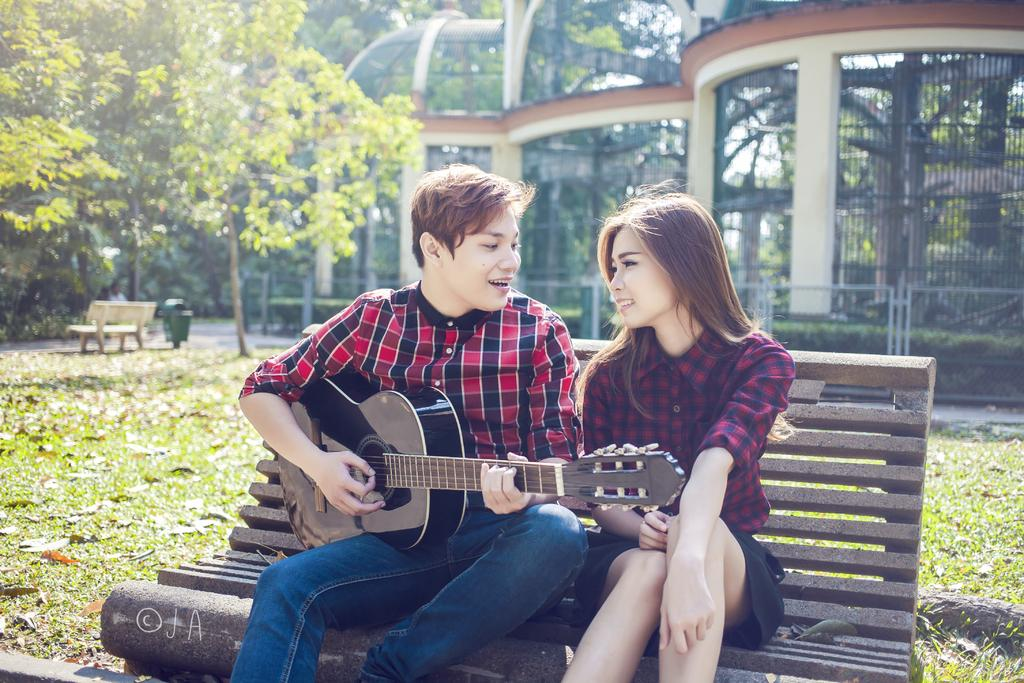Who is present in the image? There is a couple in the image. What are they doing in the image? The couple is sitting on a bench. Where is the bench located? The bench is located in a park. What is the man holding in the image? The man is holding a guitar. What is the man doing with the guitar? The man is singing. What can be seen in the background of the image? There are trees and a trash bin in the background of the image. What type of underwear is the woman wearing in the image? There is no information about the woman's underwear in the image, and it is not visible. What ornament is hanging from the tree in the background? There is no ornament hanging from the tree in the background; only trees and a trash bin are visible. 